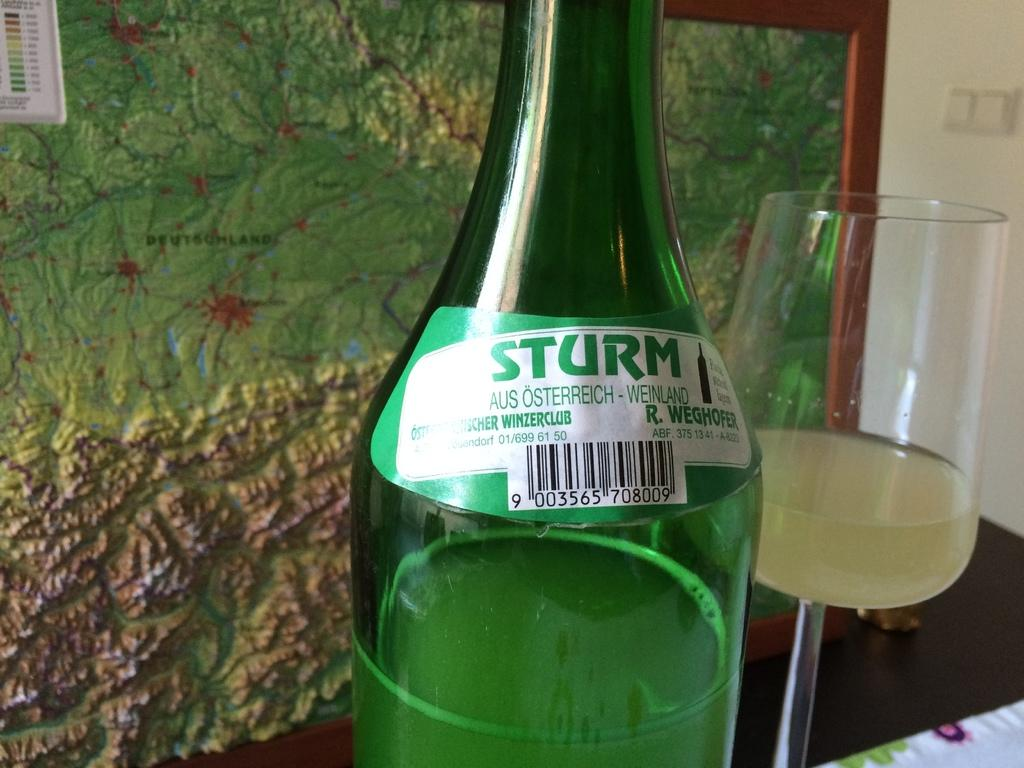<image>
Describe the image concisely. A bottle of Sturm Sits next to a wine glass that is half empty. 